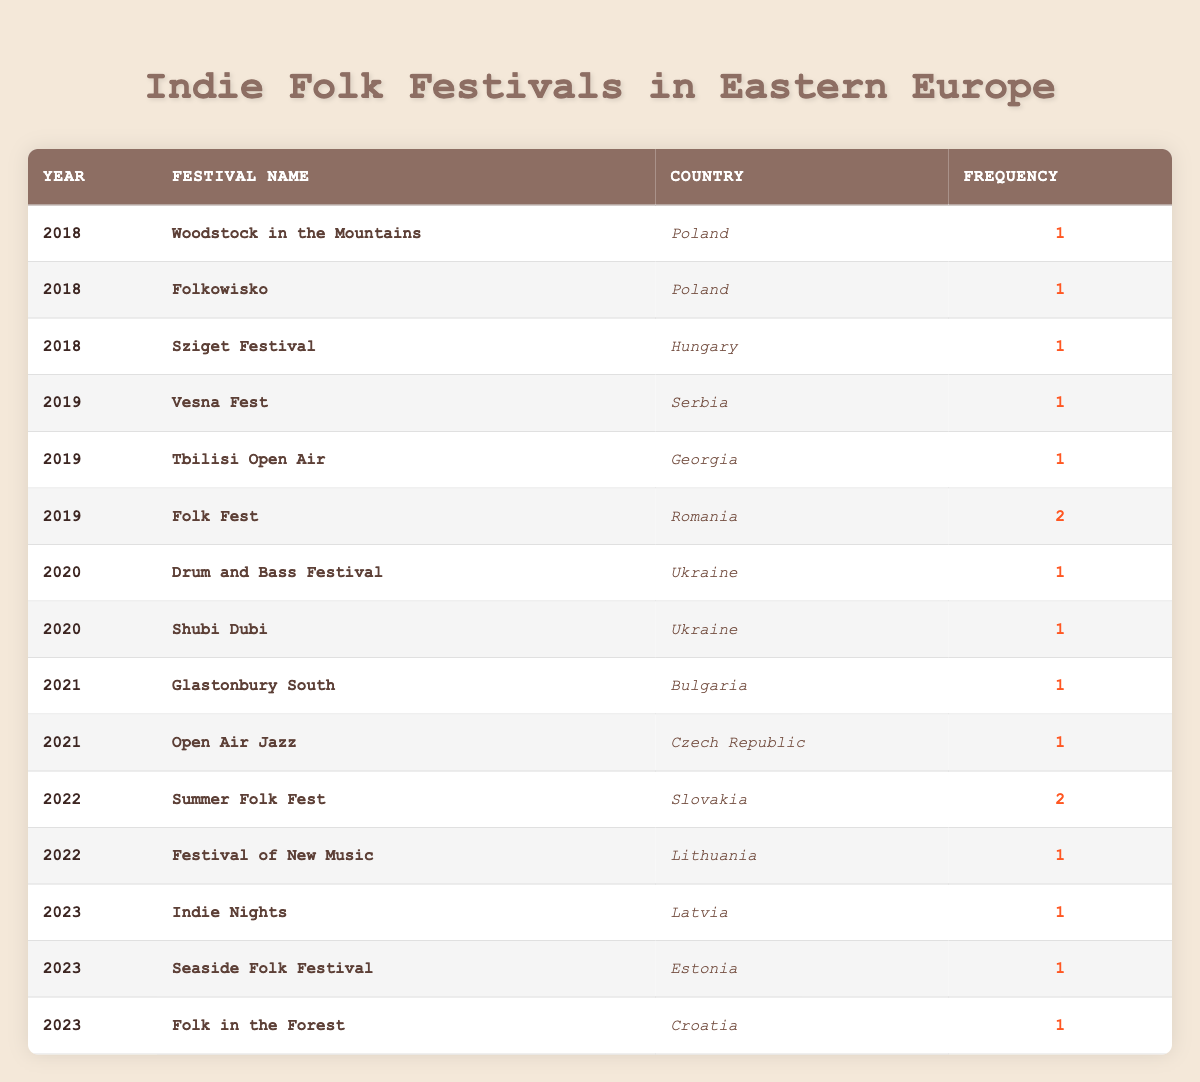What is the most frequently held indie folk festival in 2019? In 2019, the only festival with a frequency higher than 1 is "Folk Fest," which has a frequency of 2. Other festivals like "Vesna Fest" and "Tbilisi Open Air" have a frequency of 1. Thus, "Folk Fest" is the most frequently held.
Answer: Folk Fest How many indie folk festivals were held in 2022? Checking the table, there are two festivals listed for 2022: "Summer Folk Fest" and "Festival of New Music." Adding up their frequencies, the total counts to 2 (for Summer Folk) + 1 (for Festival of New Music) = 3.
Answer: 3 Which year had the highest number of indie folk festivals? In the provided data, we examine the years: 2018 had 3 festivals, 2019 had 3 festivals (one with frequency 2), 2020 had 2 festivals, 2021 had 2 festivals, 2022 had 2 festivals, and 2023 had 3 festivals. The highest number is in 2018 and 2019, both with 3.
Answer: 2018 and 2019 Was there an indie folk festival held in Georgia in 2018? Looking closely at the table, I can see that there is no festival listed in Georgia for 2018; the only Georgian festival listed is the "Tbilisi Open Air" that occurred in 2019. Therefore, it’s false.
Answer: No What is the average frequency of indie folk festivals from 2018 to 2023? To find the average frequency, I will need to calculate the total frequency across all the years and divide it by the total number of festivals. Adding them up gives 1 + 1 + 1 (2018) + 1 + 1 + 2 (2019) + 1 + 1 (2020) + 1 + 1 (2021) + 2 + 1 (2022) + 1 + 1 + 1 (2023) = 13. There are 15 festivals in total. The average frequency is 13/15 = 0.87.
Answer: 0.87 Is "Indie Nights" the only festival held in Latvia? The table shows that there is one festival listed in Latvia called "Indie Nights," with a frequency of 1. Since no other festivals are mentioned for Latvia, this statement is true.
Answer: Yes How many festivals were held in Ukraine in total? Referring to the table, there are two festivals listed from Ukraine in the year 2020, namely "Drum and Bass Festival" and "Shubi Dubi." Since both have a frequency of 1, it sums up to 2 festivals in total.
Answer: 2 What countries had an indie folk festival in 2023? The table shows three festivals for 2023: "Indie Nights" in Latvia, "Seaside Folk Festival" in Estonia, and "Folk in the Forest" in Croatia. Therefore, the countries are Latvia, Estonia, and Croatia.
Answer: Latvia, Estonia, Croatia 